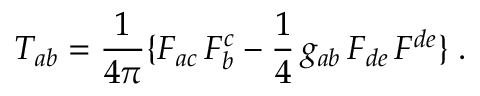<formula> <loc_0><loc_0><loc_500><loc_500>T _ { a b } = { \frac { 1 } { 4 \pi } } \{ F _ { a c } \, F _ { b } ^ { c } - { \frac { 1 } { 4 } } \, g _ { a b } \, F _ { d e } \, F ^ { d e } \} \, .</formula> 